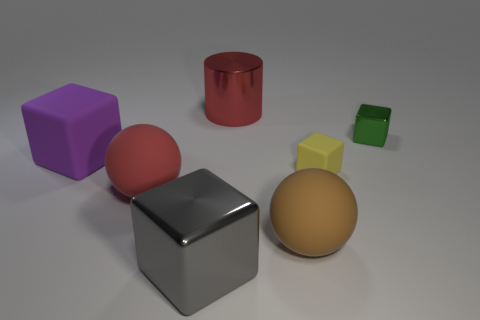Add 1 big metal cubes. How many objects exist? 8 Subtract all red balls. How many balls are left? 1 Subtract 1 cubes. How many cubes are left? 3 Subtract all cyan cylinders. Subtract all purple balls. How many cylinders are left? 1 Subtract all red spheres. Subtract all big brown matte objects. How many objects are left? 5 Add 1 tiny green objects. How many tiny green objects are left? 2 Add 6 large gray things. How many large gray things exist? 7 Subtract 1 green cubes. How many objects are left? 6 Subtract all blocks. How many objects are left? 3 